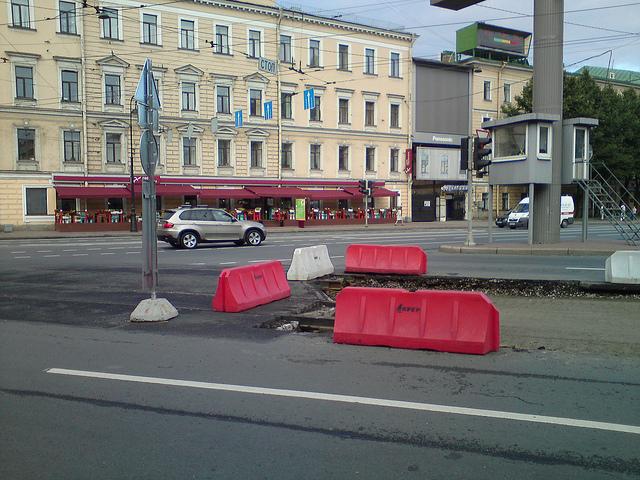What is the red object?
Short answer required. Barrier. Which two items match in color?
Be succinct. Barriers. Is it a sunny day?
Quick response, please. No. How many barricades are shown?
Give a very brief answer. 5. What color is the van behind the pole?
Short answer required. White. Are there a lot of red cars?
Write a very short answer. No. Are they outside?
Write a very short answer. Yes. What kind of equipment is this?
Answer briefly. Car. 